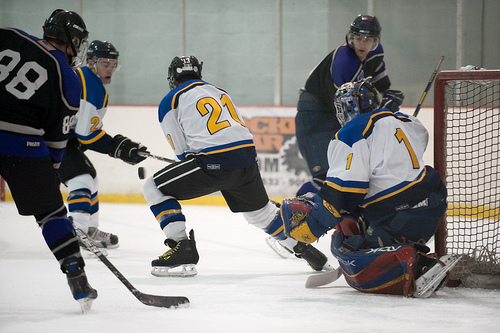<image>
Is the puck in front of the person? Yes. The puck is positioned in front of the person, appearing closer to the camera viewpoint. 